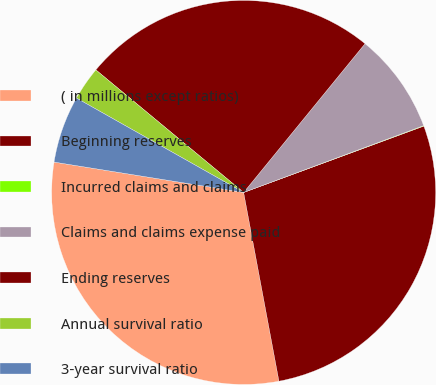Convert chart to OTSL. <chart><loc_0><loc_0><loc_500><loc_500><pie_chart><fcel>( in millions except ratios)<fcel>Beginning reserves<fcel>Incurred claims and claims<fcel>Claims and claims expense paid<fcel>Ending reserves<fcel>Annual survival ratio<fcel>3-year survival ratio<nl><fcel>30.47%<fcel>27.67%<fcel>0.04%<fcel>8.45%<fcel>24.87%<fcel>2.84%<fcel>5.65%<nl></chart> 